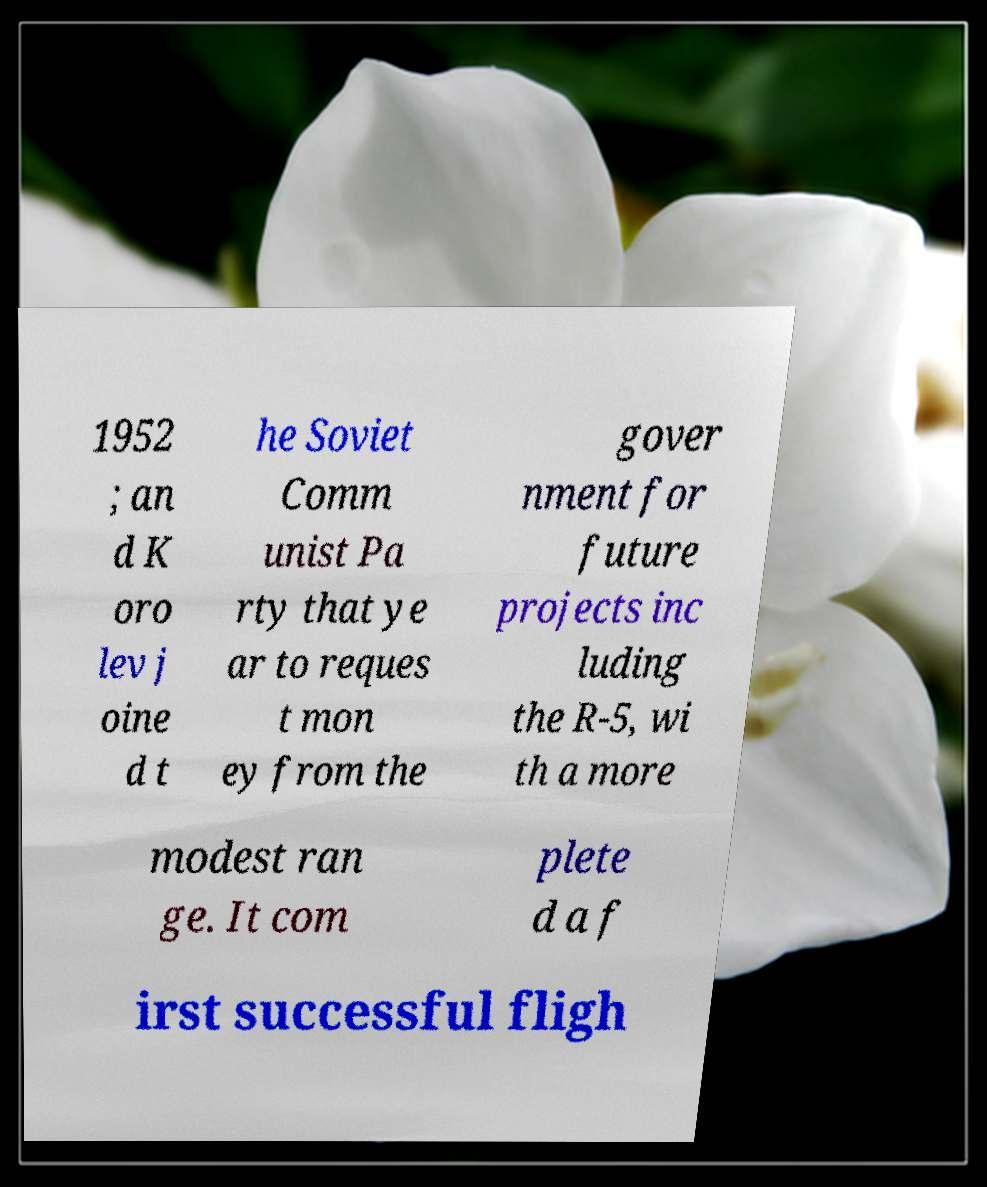Please identify and transcribe the text found in this image. 1952 ; an d K oro lev j oine d t he Soviet Comm unist Pa rty that ye ar to reques t mon ey from the gover nment for future projects inc luding the R-5, wi th a more modest ran ge. It com plete d a f irst successful fligh 